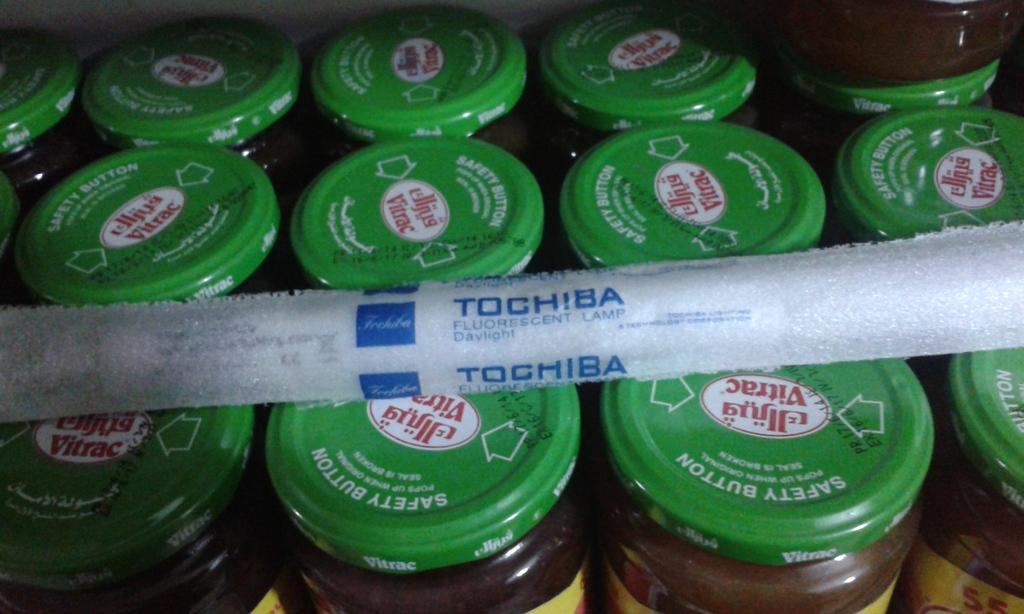Provide a one-sentence caption for the provided image. the tochiba sits on top of the jars with green tops. 